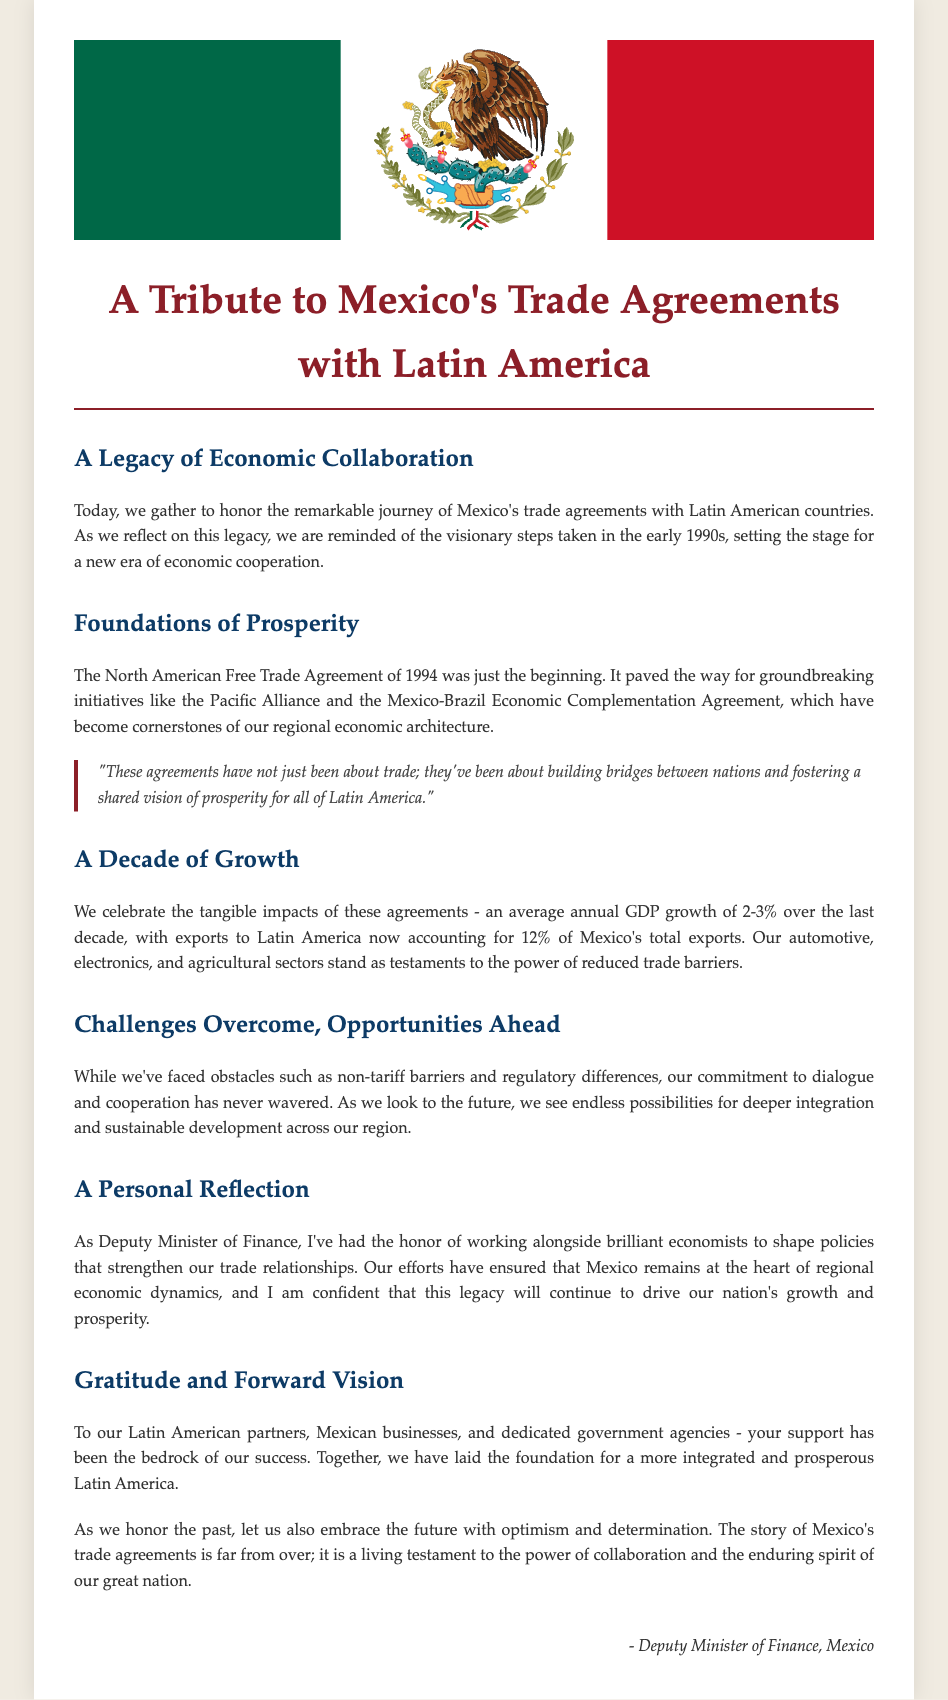What year did the North American Free Trade Agreement begin? The document states that the North American Free Trade Agreement began in 1994.
Answer: 1994 What percentage do exports to Latin America account for Mexico's total exports? The document mentions that exports to Latin America account for 12% of Mexico's total exports.
Answer: 12% Which sectors are highlighted as testaments to the power of reduced trade barriers? The document identifies automotive, electronics, and agricultural sectors as key sectors impacted by trade agreements.
Answer: Automotive, electronics, agricultural What is the average annual GDP growth over the last decade? The document states that the average annual GDP growth has been 2-3% over the last decade.
Answer: 2-3% What are the foundational agreements mentioned in the document? The foundational agreements are the North American Free Trade Agreement, the Pacific Alliance, and the Mexico-Brazil Economic Complementation Agreement.
Answer: North American Free Trade Agreement, Pacific Alliance, Mexico-Brazil Economic Complementation Agreement What is emphasized as a major challenge in trade agreements? The document highlights non-tariff barriers and regulatory differences as significant challenges faced in trade agreements.
Answer: Non-tariff barriers Who is the author of the document? The document is attributed to the Deputy Minister of Finance in Mexico as the author.
Answer: Deputy Minister of Finance, Mexico What type of future does the document envision for trade agreements in Latin America? The document expresses optimism and determination for a more integrated and prosperous future in Latin America.
Answer: Integrated and prosperous future 